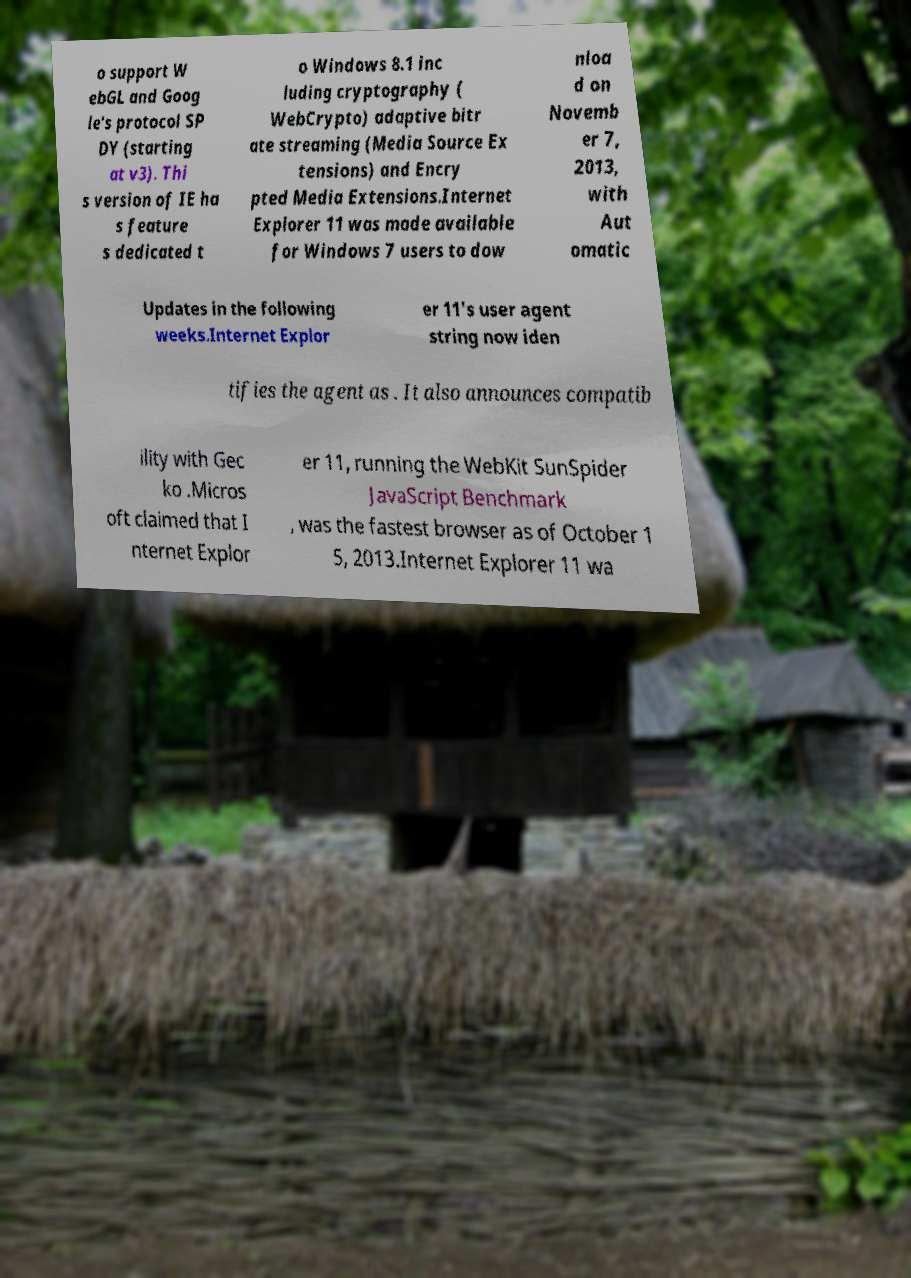What messages or text are displayed in this image? I need them in a readable, typed format. o support W ebGL and Goog le's protocol SP DY (starting at v3). Thi s version of IE ha s feature s dedicated t o Windows 8.1 inc luding cryptography ( WebCrypto) adaptive bitr ate streaming (Media Source Ex tensions) and Encry pted Media Extensions.Internet Explorer 11 was made available for Windows 7 users to dow nloa d on Novemb er 7, 2013, with Aut omatic Updates in the following weeks.Internet Explor er 11's user agent string now iden tifies the agent as . It also announces compatib ility with Gec ko .Micros oft claimed that I nternet Explor er 11, running the WebKit SunSpider JavaScript Benchmark , was the fastest browser as of October 1 5, 2013.Internet Explorer 11 wa 